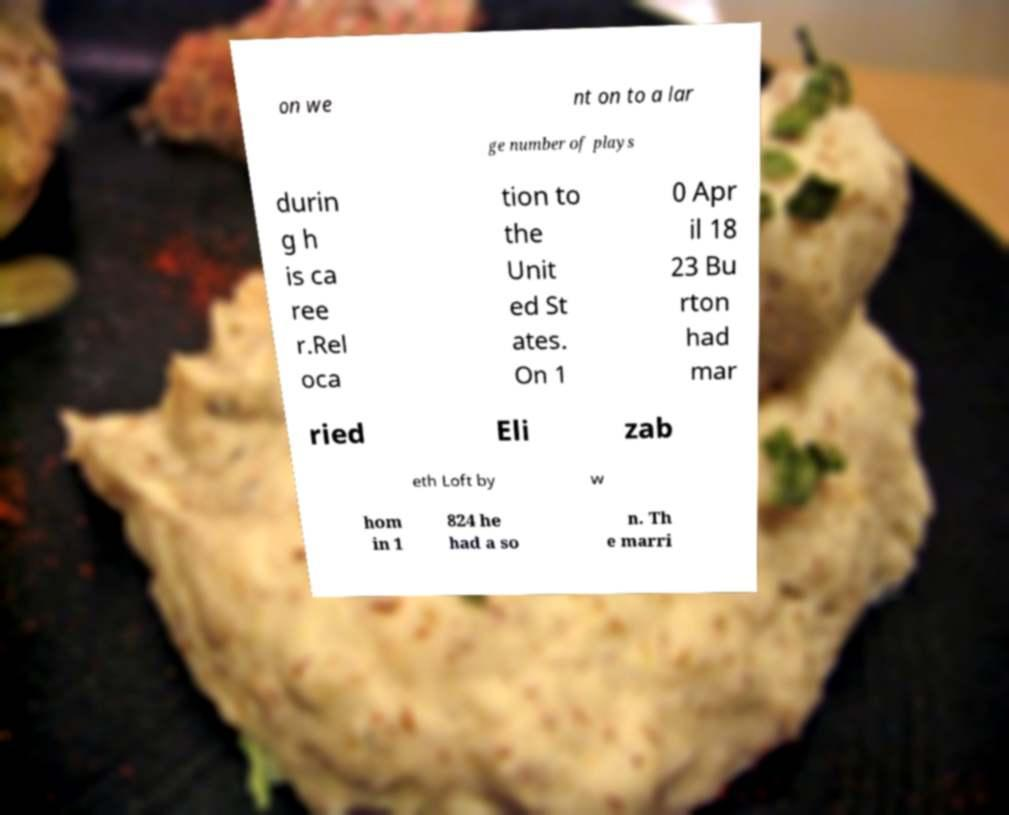Can you read and provide the text displayed in the image?This photo seems to have some interesting text. Can you extract and type it out for me? on we nt on to a lar ge number of plays durin g h is ca ree r.Rel oca tion to the Unit ed St ates. On 1 0 Apr il 18 23 Bu rton had mar ried Eli zab eth Loft by w hom in 1 824 he had a so n. Th e marri 